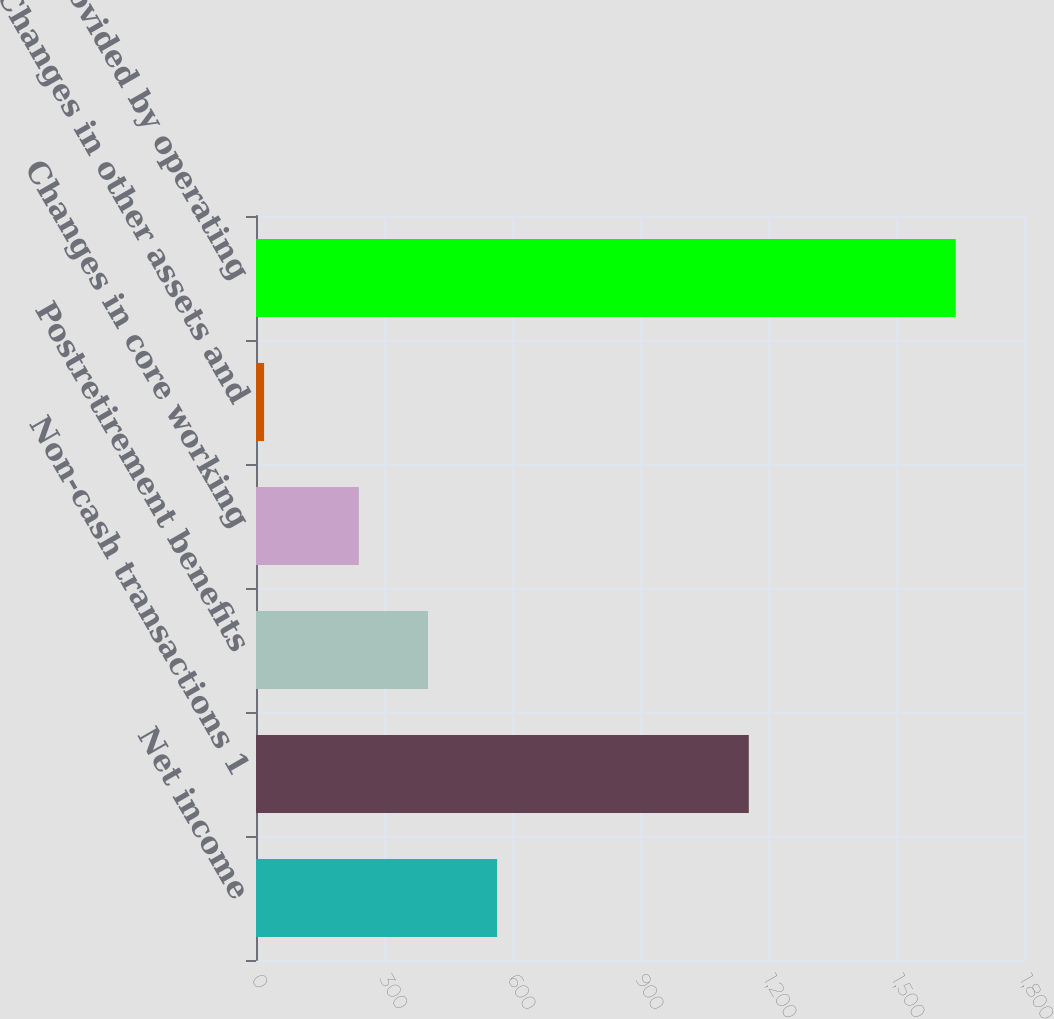Convert chart. <chart><loc_0><loc_0><loc_500><loc_500><bar_chart><fcel>Net income<fcel>Non-cash transactions 1<fcel>Postretirement benefits<fcel>Changes in core working<fcel>Changes in other assets and<fcel>Net cash provided by operating<nl><fcel>565.2<fcel>1155<fcel>403.1<fcel>241<fcel>19<fcel>1640<nl></chart> 